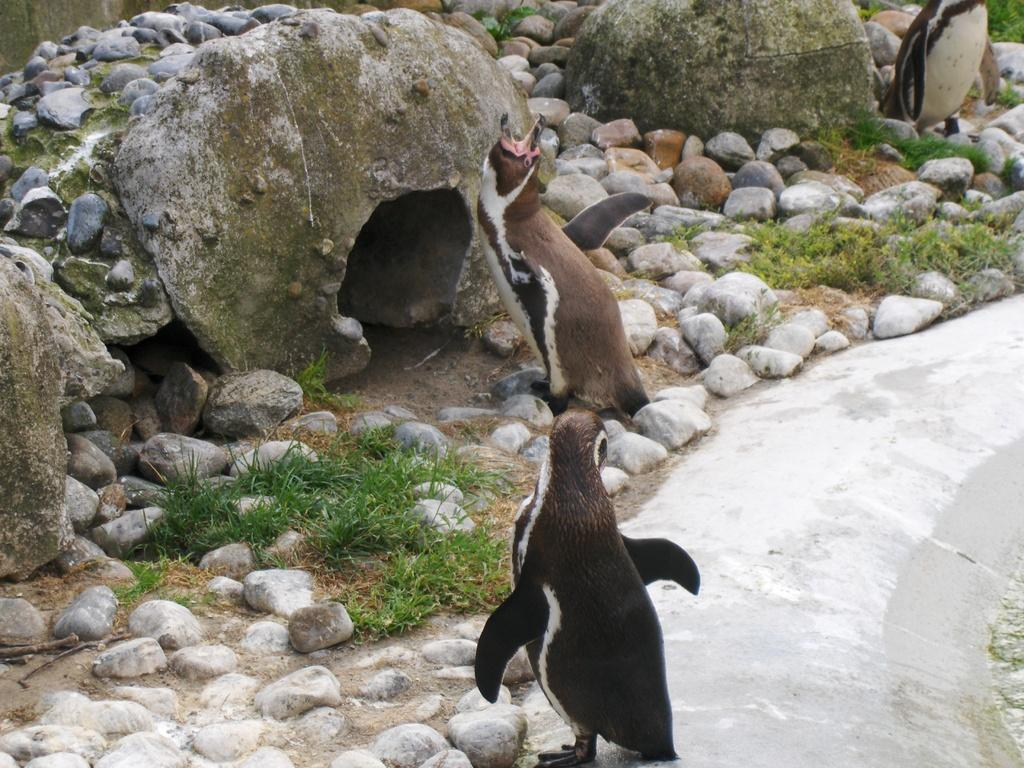What type of animals are in the image? There are penguins in the image. Where are the penguins located? The penguins are on the ground. What other elements can be seen in the image? There are stones and grass in the image. What type of window can be seen in the image? There is no window present in the image; it features penguins on the ground with stones and grass. 